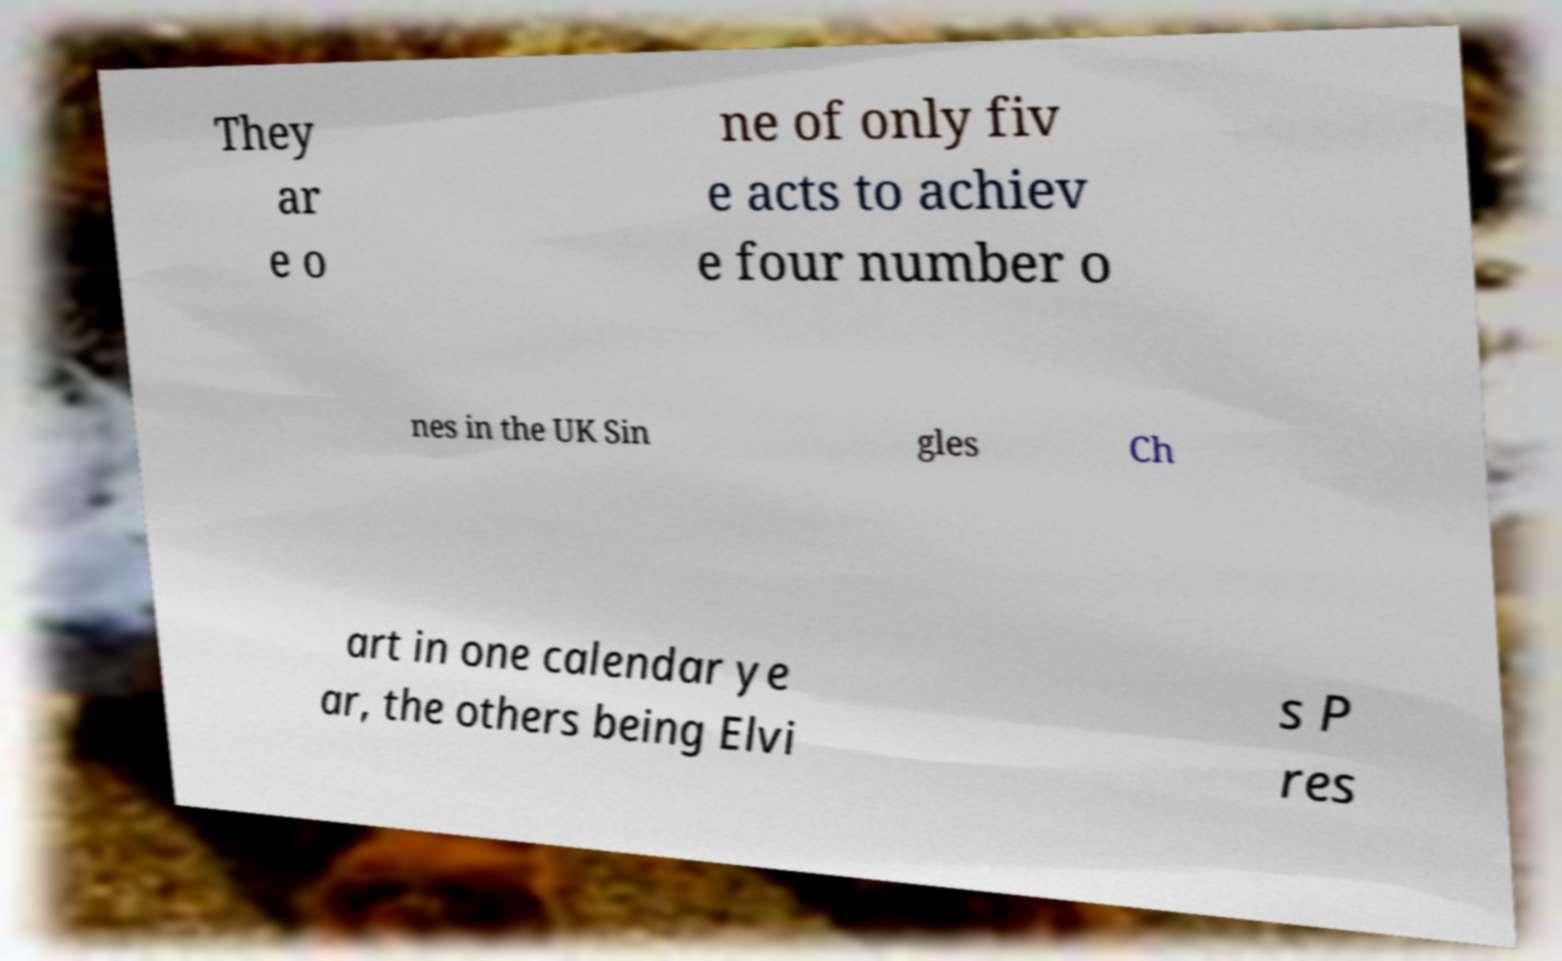Please identify and transcribe the text found in this image. They ar e o ne of only fiv e acts to achiev e four number o nes in the UK Sin gles Ch art in one calendar ye ar, the others being Elvi s P res 